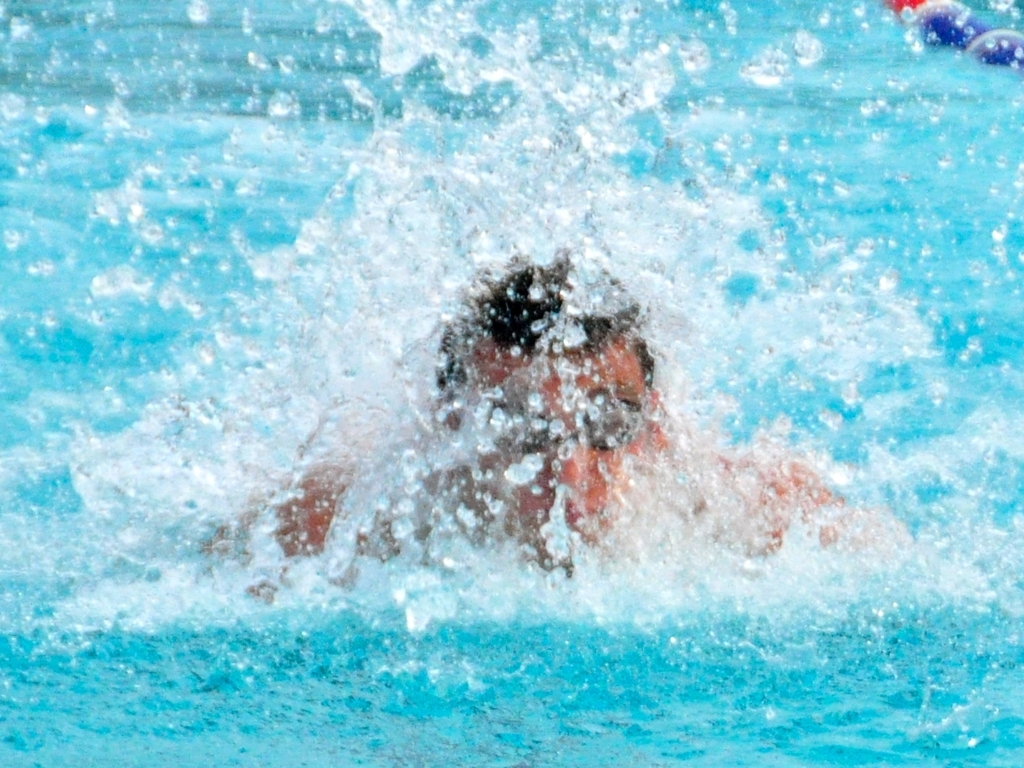What could be happening outside this frame? Beyond the frame, one might envision a competitive setting with other swimmers vigorously propelling themselves through the water, spectators cheering from the stands, coaches closely observing the athletes' performances, and the presence of timekeepers and judges monitoring the race. 